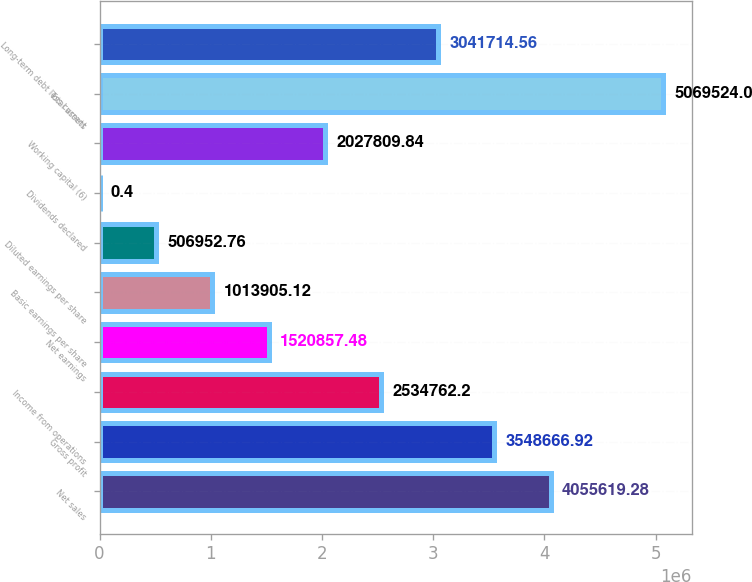Convert chart to OTSL. <chart><loc_0><loc_0><loc_500><loc_500><bar_chart><fcel>Net sales<fcel>Gross profit<fcel>Income from operations<fcel>Net earnings<fcel>Basic earnings per share<fcel>Diluted earnings per share<fcel>Dividends declared<fcel>Working capital (6)<fcel>Total assets<fcel>Long-term debt less current<nl><fcel>4.05562e+06<fcel>3.54867e+06<fcel>2.53476e+06<fcel>1.52086e+06<fcel>1.01391e+06<fcel>506953<fcel>0.4<fcel>2.02781e+06<fcel>5.06952e+06<fcel>3.04171e+06<nl></chart> 